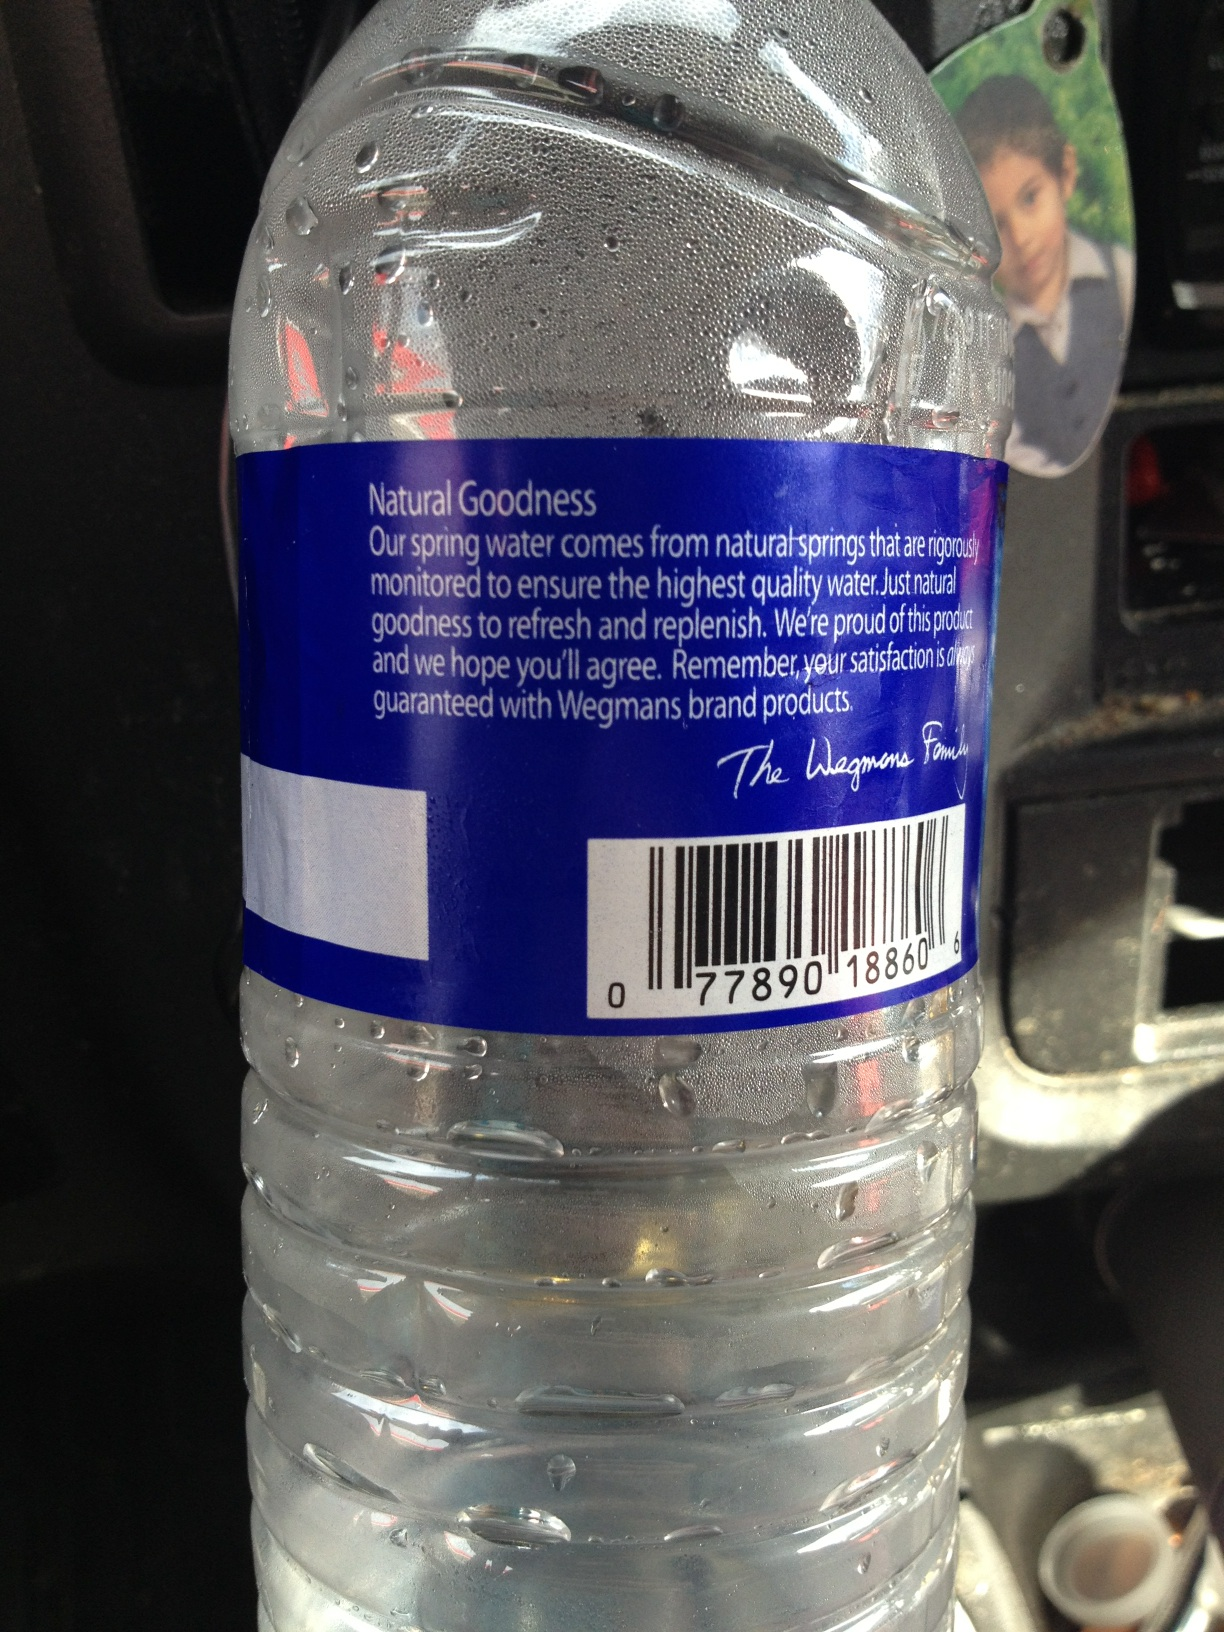Can you write a short marketing pitch for this water bottle? Experience the pure refreshment of Wegmans Natural Spring Water. Sourced from carefully monitored natural springs, each bottle promises the highest quality and natural goodness. Whether you’re at the gym, office, or on-the-go, stay hydrated and refreshed with Wegmans. 